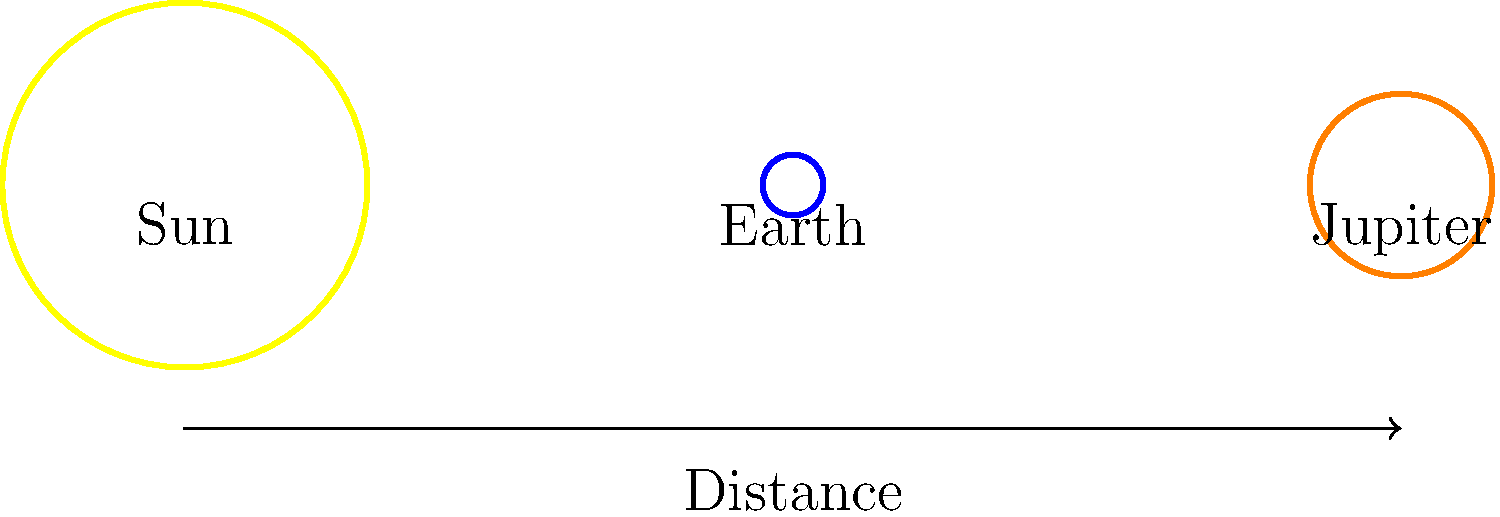In the context of optimizing PHP-based astronomy applications for Google Ads campaigns, consider the diagram representing the Sun, Earth, and Jupiter (not to scale). If the distance between the Sun and Earth is approximately 1 Astronomical Unit (AU), and Jupiter's distance from the Sun is about 5.2 AU, what is the ratio of Jupiter's volume to Earth's volume, rounded to the nearest whole number? To solve this problem, let's follow these steps:

1. Recall that the volume of a sphere is proportional to the cube of its radius: $V \propto r^3$

2. In the diagram, we can see that:
   - Earth's radius is 5 units
   - Jupiter's radius is 15 units

3. Calculate the ratio of the radii:
   $\frac{r_{Jupiter}}{r_{Earth}} = \frac{15}{5} = 3$

4. To find the volume ratio, we need to cube this ratio:
   $\frac{V_{Jupiter}}{V_{Earth}} = (\frac{r_{Jupiter}}{r_{Earth}})^3 = 3^3 = 27$

5. Round to the nearest whole number:
   27 (no rounding needed in this case)

Therefore, Jupiter's volume is approximately 27 times that of Earth.

This knowledge is crucial for PHP developers working on astronomy-related web applications, especially when optimizing content for Google Ads campaigns targeting space enthusiasts or educational institutions.
Answer: 27 